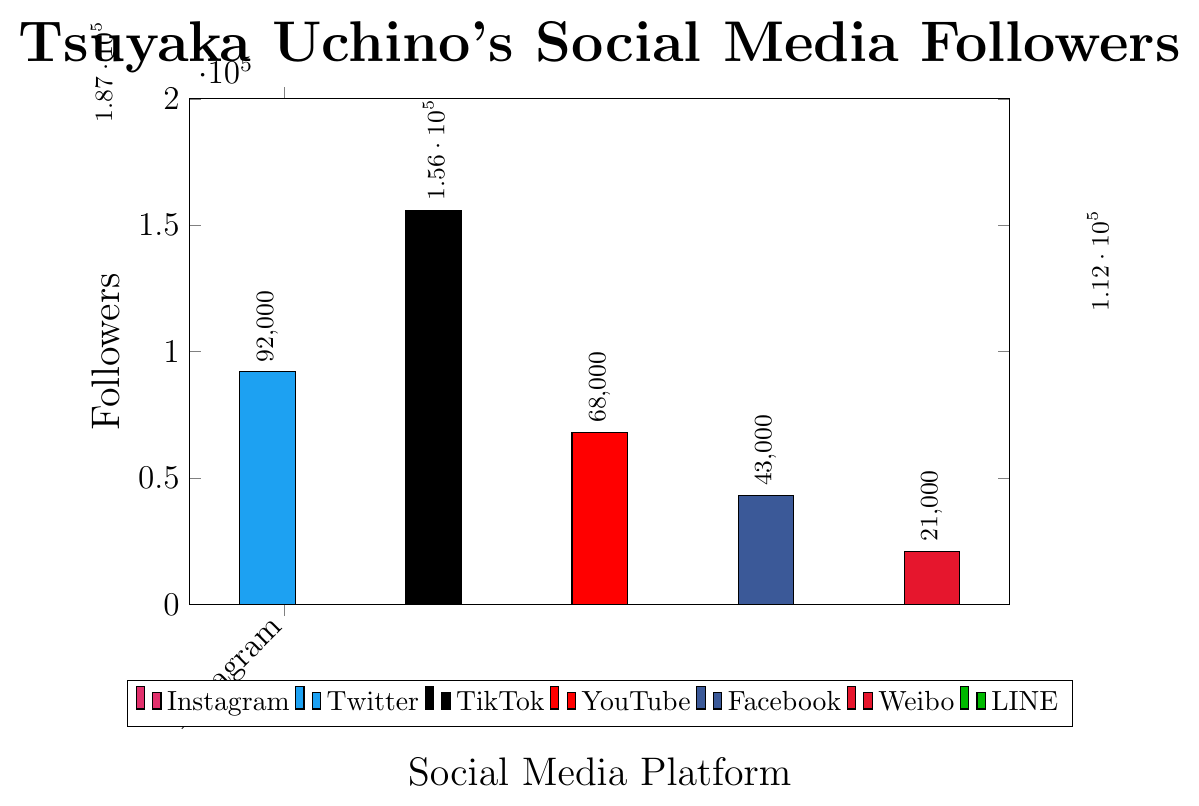Which social media platform has the highest follower count for Tsuyaka Uchino? The bar corresponding to Instagram has the maximum height, indicating the highest follower count.
Answer: Instagram Which social media platform has the lowest follower count for Tsuyaka Uchino? The bar corresponding to Weibo has the minimum height, indicating the lowest follower count.
Answer: Weibo How many more followers does Tsuyaka Uchino have on Instagram compared to Twitter? The height of the Instagram bar indicates 187000 followers, and the height of the Twitter bar indicates 92000 followers. The difference is 187000 - 92000 = 95000.
Answer: 95000 What is the total number of followers Tsuyaka Uchino has across all platforms? Sum the follower counts for all platforms: 187000 (Instagram) + 92000 (Twitter) + 156000 (TikTok) + 68000 (YouTube) + 43000 (Facebook) + 21000 (Weibo) + 112000 (LINE) = 679000.
Answer: 679000 Which social media platform has fewer followers for Tsuyaka Uchino, YouTube or TikTok? The height of the YouTube bar indicates 68000 followers, and the height of the TikTok bar indicates 156000 followers. We can see that YouTube has fewer followers.
Answer: YouTube What is the average number of followers across YouTube, Facebook, and Weibo? Sum the followers of YouTube (68000), Facebook (43000), and Weibo (21000), then divide by 3: (68000 + 43000 + 21000) / 3 = 44000.
Answer: 44000 Arrange the social media platforms in decreasing order of follower count. The order from highest to lowest follower count based on bar heights is: Instagram, TikTok, LINE, Twitter, YouTube, Facebook, Weibo.
Answer: Instagram, TikTok, LINE, Twitter, YouTube, Facebook, Weibo How many times more followers does Tsuyaka Uchino have on Instagram compared to Weibo? Instagram has 187000 followers and Weibo has 21000 followers. 187000 / 21000 ≈ 8.905, so approximately 9 times more followers.
Answer: 9 times What is the difference in follower count between the platform with the second highest followers and the one with the second lowest followers? TikTok has the second-highest followers with 156000, and YouTube has the second-lowest followers with 68000. The difference is 156000 - 68000 = 88000.
Answer: 88000 